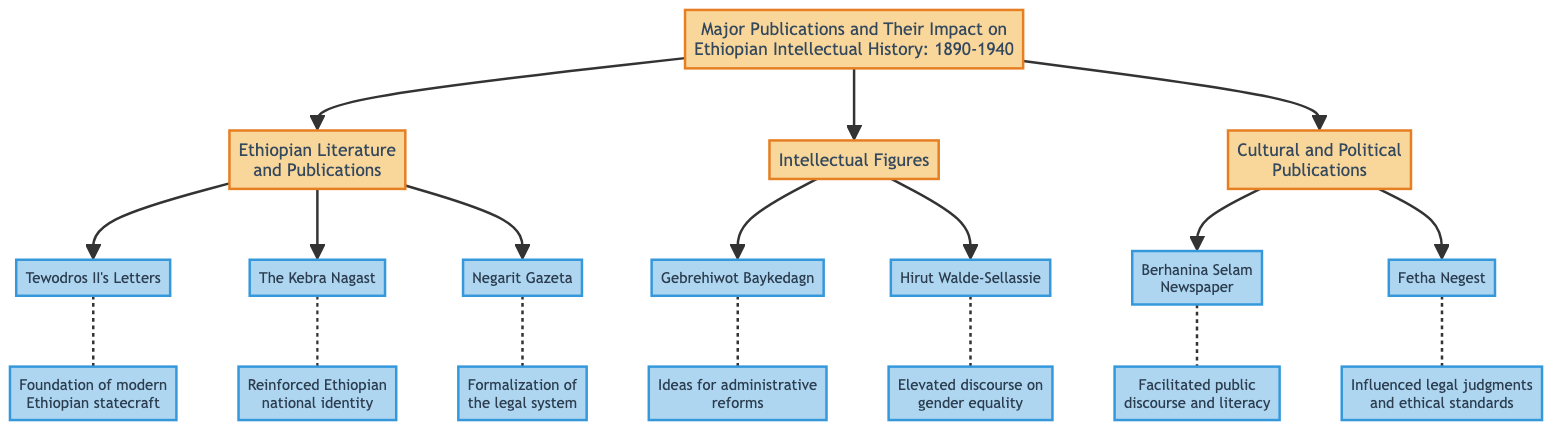What is the main title of the diagram? The main title is found at the top of the diagram and states the overall theme of the publication, which is about significant works and their influence on Ethiopian intellectual history during a specific period.
Answer: Major Publications and Their Impact on Ethiopian Intellectual History: 1890-1940 How many main categories are presented in the diagram? The diagram is divided into three main categories, which are displayed as distinct blocks. By counting these blocks, we ascertain the number of categories.
Answer: 3 Which publication is associated with the formalization of the legal system? By examining the impact descriptions in the diagram, we identify which publication specifically discusses the legal system. The correct publication is linked to enhancing governance and legal awareness.
Answer: Negarit Gazeta Name one intellectual figure associated with gender equality discourse. The diagram lists intellectual figures, with their descriptions including areas of focus. By reading the descriptions, we find the figure addressing gender equality.
Answer: Hirut Walde-Sellassie What publication reinforced Ethiopian national identity? The answer can be found by locating the publication that explicitly mentions reinforcing national identity in the impact section, connecting it to the historical context.
Answer: The Kebra Nagast What is the impact of "Berhanina Selam Newspaper"? The impact of "Berhanina Selam Newspaper" is highlighted in the diagram, specifically addressing its contributions to public discourse and literacy. This can be directly referenced from the impact label.
Answer: Facilitated public discourse and literacy Which publication was authored by Gebrehiwot Baykedagn? By checking the intellectual figures block, we identify the specific work attributed to Gebrehiwot Baykedagn as it is mentioned alongside the author's description.
Answer: Mengistina Yehizb Astadadar How does Tewodros II's Letters contribute to Ethiopian statecraft? To answer this, we examine the impact description related to Tewodros II’s Letters, which explains its role in statecraft and diplomatic engagements.
Answer: Foundation of modern Ethiopian statecraft What type of publication is Fetha Negest? Fetha Negest is categorized under cultural and political publications in the diagram, which informs us about its type, specifically focusing on legal aspects.
Answer: Legal code text 